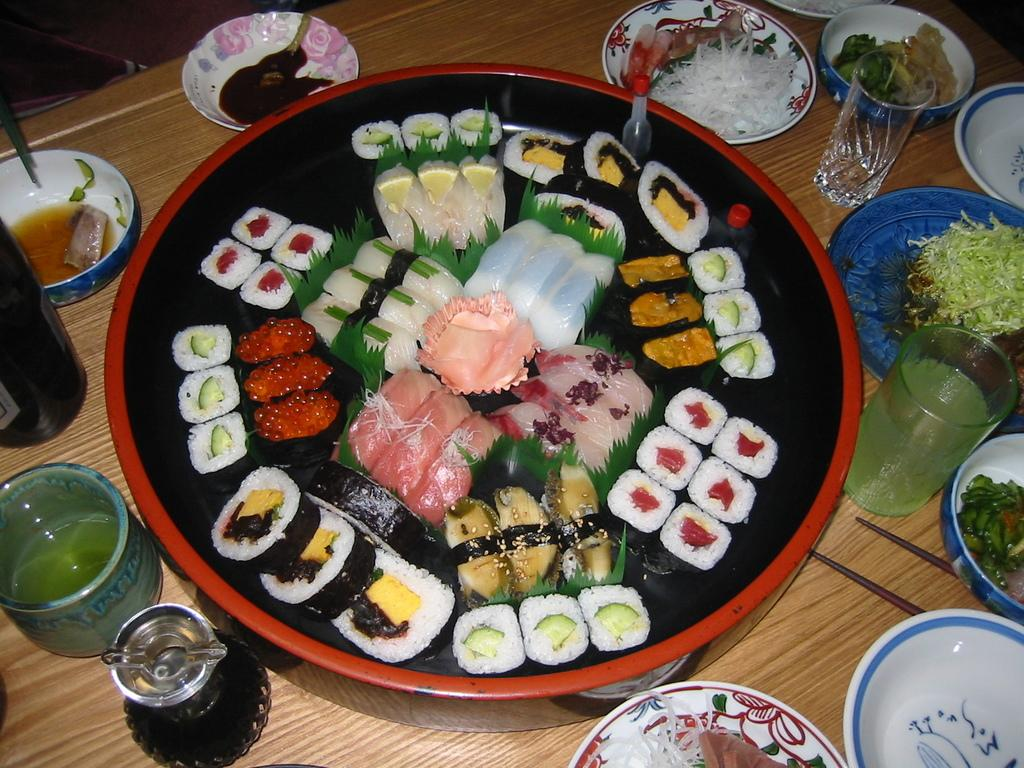What type of food items can be seen in the image? There are food items in the image, but their specific types are not mentioned. How are the food items arranged in the image? The food items are in bowls and plates, which are placed on a wooden table. What utensils are visible in the image? Chopsticks are visible in the image. What type of containers are present in the image? Containers are visible in the image, but their specific types are not mentioned. What type of glasses are present in the image? Glasses are present in the image, but their specific types are not mentioned. What is the material of the table in the image? The table in the image is made of wood. What type of insurance policy is being discussed in the image? There is no mention of insurance or any discussion in the image. 